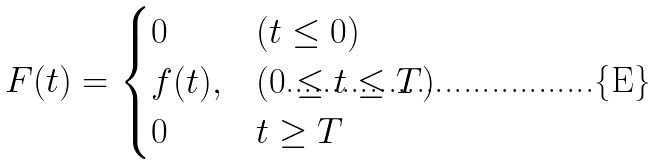Convert formula to latex. <formula><loc_0><loc_0><loc_500><loc_500>F ( t ) = \begin{cases} 0 & ( t \leq 0 ) \\ f ( t ) , & ( 0 \leq t \leq T ) \\ 0 & t \geq T \end{cases}</formula> 